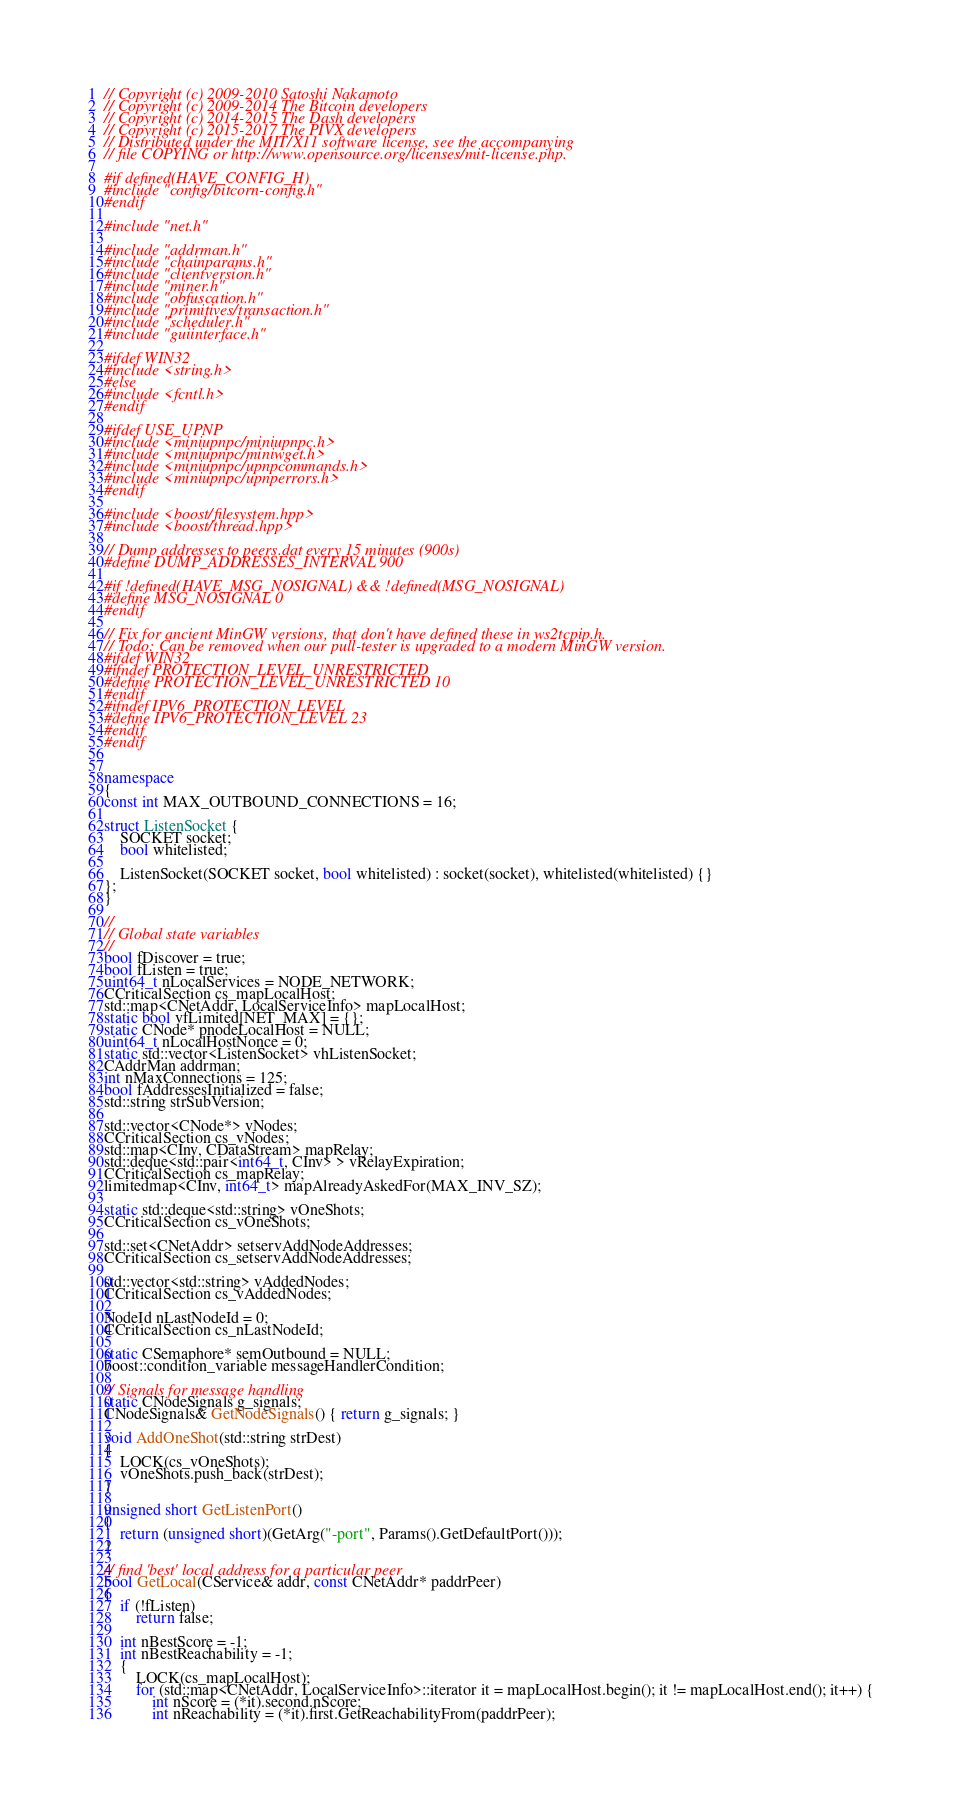Convert code to text. <code><loc_0><loc_0><loc_500><loc_500><_C++_>// Copyright (c) 2009-2010 Satoshi Nakamoto
// Copyright (c) 2009-2014 The Bitcoin developers
// Copyright (c) 2014-2015 The Dash developers
// Copyright (c) 2015-2017 The PIVX developers
// Distributed under the MIT/X11 software license, see the accompanying
// file COPYING or http://www.opensource.org/licenses/mit-license.php.

#if defined(HAVE_CONFIG_H)
#include "config/bitcorn-config.h"
#endif

#include "net.h"

#include "addrman.h"
#include "chainparams.h"
#include "clientversion.h"
#include "miner.h"
#include "obfuscation.h"
#include "primitives/transaction.h"
#include "scheduler.h"
#include "guiinterface.h"

#ifdef WIN32
#include <string.h>
#else
#include <fcntl.h>
#endif

#ifdef USE_UPNP
#include <miniupnpc/miniupnpc.h>
#include <miniupnpc/miniwget.h>
#include <miniupnpc/upnpcommands.h>
#include <miniupnpc/upnperrors.h>
#endif

#include <boost/filesystem.hpp>
#include <boost/thread.hpp>

// Dump addresses to peers.dat every 15 minutes (900s)
#define DUMP_ADDRESSES_INTERVAL 900

#if !defined(HAVE_MSG_NOSIGNAL) && !defined(MSG_NOSIGNAL)
#define MSG_NOSIGNAL 0
#endif

// Fix for ancient MinGW versions, that don't have defined these in ws2tcpip.h.
// Todo: Can be removed when our pull-tester is upgraded to a modern MinGW version.
#ifdef WIN32
#ifndef PROTECTION_LEVEL_UNRESTRICTED
#define PROTECTION_LEVEL_UNRESTRICTED 10
#endif
#ifndef IPV6_PROTECTION_LEVEL
#define IPV6_PROTECTION_LEVEL 23
#endif
#endif


namespace
{
const int MAX_OUTBOUND_CONNECTIONS = 16;

struct ListenSocket {
    SOCKET socket;
    bool whitelisted;

    ListenSocket(SOCKET socket, bool whitelisted) : socket(socket), whitelisted(whitelisted) {}
};
}

//
// Global state variables
//
bool fDiscover = true;
bool fListen = true;
uint64_t nLocalServices = NODE_NETWORK;
CCriticalSection cs_mapLocalHost;
std::map<CNetAddr, LocalServiceInfo> mapLocalHost;
static bool vfLimited[NET_MAX] = {};
static CNode* pnodeLocalHost = NULL;
uint64_t nLocalHostNonce = 0;
static std::vector<ListenSocket> vhListenSocket;
CAddrMan addrman;
int nMaxConnections = 125;
bool fAddressesInitialized = false;
std::string strSubVersion;

std::vector<CNode*> vNodes;
CCriticalSection cs_vNodes;
std::map<CInv, CDataStream> mapRelay;
std::deque<std::pair<int64_t, CInv> > vRelayExpiration;
CCriticalSection cs_mapRelay;
limitedmap<CInv, int64_t> mapAlreadyAskedFor(MAX_INV_SZ);

static std::deque<std::string> vOneShots;
CCriticalSection cs_vOneShots;

std::set<CNetAddr> setservAddNodeAddresses;
CCriticalSection cs_setservAddNodeAddresses;

std::vector<std::string> vAddedNodes;
CCriticalSection cs_vAddedNodes;

NodeId nLastNodeId = 0;
CCriticalSection cs_nLastNodeId;

static CSemaphore* semOutbound = NULL;
boost::condition_variable messageHandlerCondition;

// Signals for message handling
static CNodeSignals g_signals;
CNodeSignals& GetNodeSignals() { return g_signals; }

void AddOneShot(std::string strDest)
{
    LOCK(cs_vOneShots);
    vOneShots.push_back(strDest);
}

unsigned short GetListenPort()
{
    return (unsigned short)(GetArg("-port", Params().GetDefaultPort()));
}

// find 'best' local address for a particular peer
bool GetLocal(CService& addr, const CNetAddr* paddrPeer)
{
    if (!fListen)
        return false;

    int nBestScore = -1;
    int nBestReachability = -1;
    {
        LOCK(cs_mapLocalHost);
        for (std::map<CNetAddr, LocalServiceInfo>::iterator it = mapLocalHost.begin(); it != mapLocalHost.end(); it++) {
            int nScore = (*it).second.nScore;
            int nReachability = (*it).first.GetReachabilityFrom(paddrPeer);</code> 